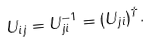<formula> <loc_0><loc_0><loc_500><loc_500>U _ { i j } = U _ { j i } ^ { - 1 } = ( U _ { j i } ) ^ { \dagger } .</formula> 